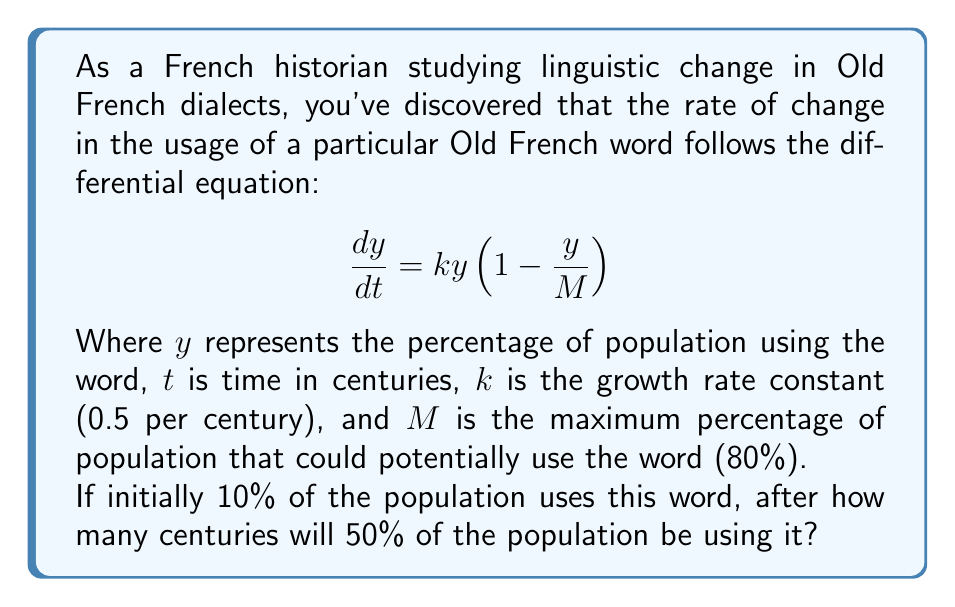Help me with this question. To solve this problem, we need to use the logistic growth model, which is described by the given differential equation. Let's approach this step-by-step:

1) The general solution to this logistic differential equation is:

   $$y(t) = \frac{M}{1 + (\frac{M}{y_0} - 1)e^{-kt}}$$

   Where $y_0$ is the initial value of $y$ at $t=0$.

2) We're given:
   $M = 80\%$
   $k = 0.5$ per century
   $y_0 = 10\%$
   We need to find $t$ when $y = 50\%$

3) Let's substitute these values into the equation:

   $$50 = \frac{80}{1 + (\frac{80}{10} - 1)e^{-0.5t}}$$

4) Simplify:

   $$50 = \frac{80}{1 + 7e^{-0.5t}}$$

5) Multiply both sides by $(1 + 7e^{-0.5t})$:

   $$50(1 + 7e^{-0.5t}) = 80$$

6) Expand:

   $$50 + 350e^{-0.5t} = 80$$

7) Subtract 50 from both sides:

   $$350e^{-0.5t} = 30$$

8) Divide both sides by 350:

   $$e^{-0.5t} = \frac{3}{35}$$

9) Take the natural log of both sides:

   $$-0.5t = \ln(\frac{3}{35})$$

10) Divide both sides by -0.5:

    $$t = -\frac{2\ln(\frac{3}{35})}{1} \approx 4.97$$

Therefore, it will take approximately 4.97 centuries for 50% of the population to be using the word.
Answer: 4.97 centuries 